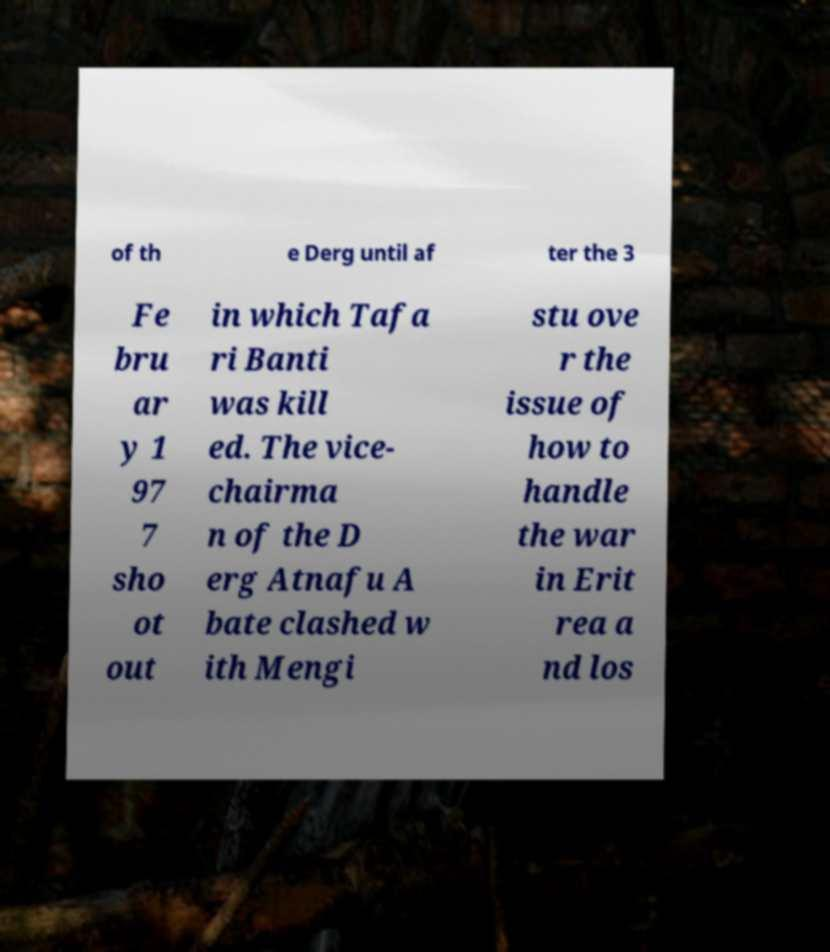There's text embedded in this image that I need extracted. Can you transcribe it verbatim? of th e Derg until af ter the 3 Fe bru ar y 1 97 7 sho ot out in which Tafa ri Banti was kill ed. The vice- chairma n of the D erg Atnafu A bate clashed w ith Mengi stu ove r the issue of how to handle the war in Erit rea a nd los 